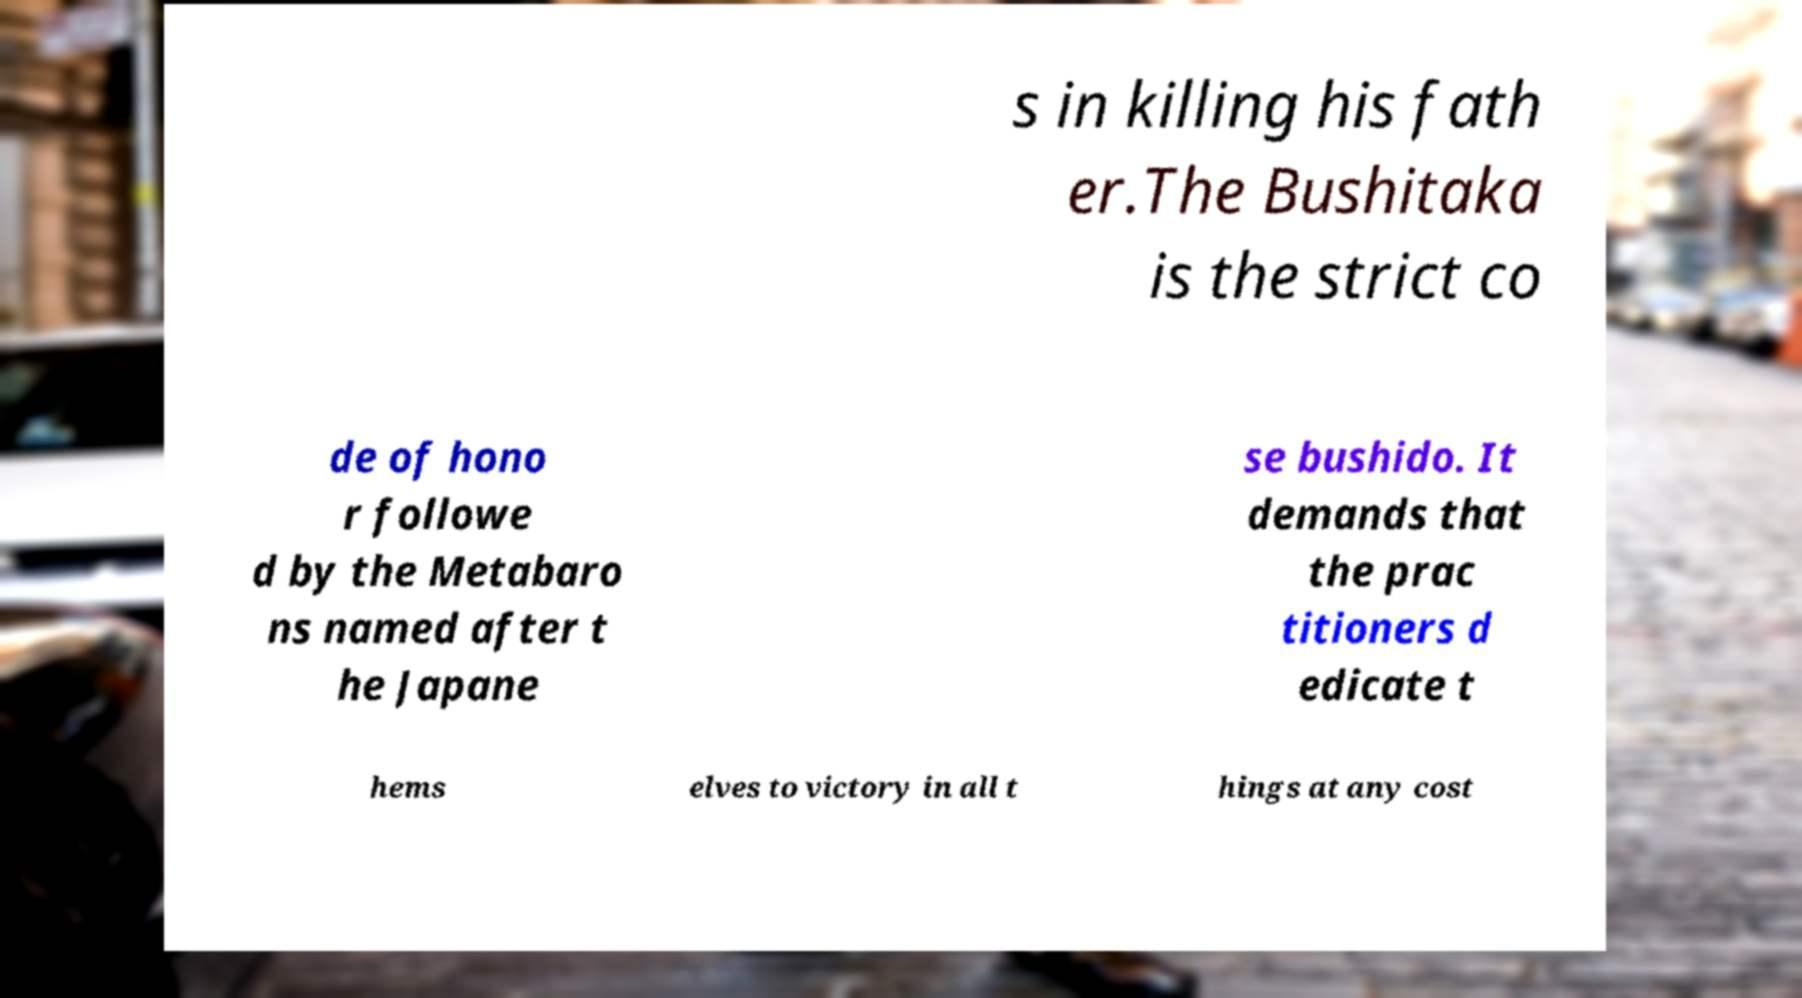Can you accurately transcribe the text from the provided image for me? s in killing his fath er.The Bushitaka is the strict co de of hono r followe d by the Metabaro ns named after t he Japane se bushido. It demands that the prac titioners d edicate t hems elves to victory in all t hings at any cost 